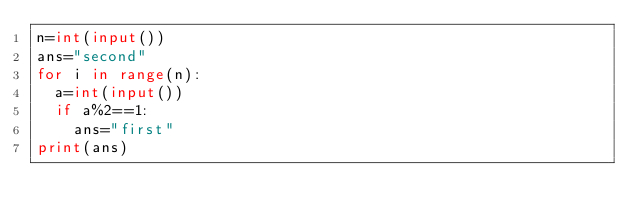<code> <loc_0><loc_0><loc_500><loc_500><_Python_>n=int(input())
ans="second"
for i in range(n):
  a=int(input())
  if a%2==1:
    ans="first"
print(ans)</code> 